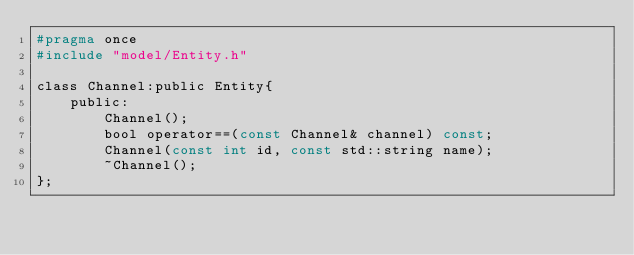Convert code to text. <code><loc_0><loc_0><loc_500><loc_500><_C_>#pragma once
#include "model/Entity.h"

class Channel:public Entity{
	public:
		Channel();
		bool operator==(const Channel& channel) const;
		Channel(const int id, const std::string name);
		~Channel();
};
</code> 